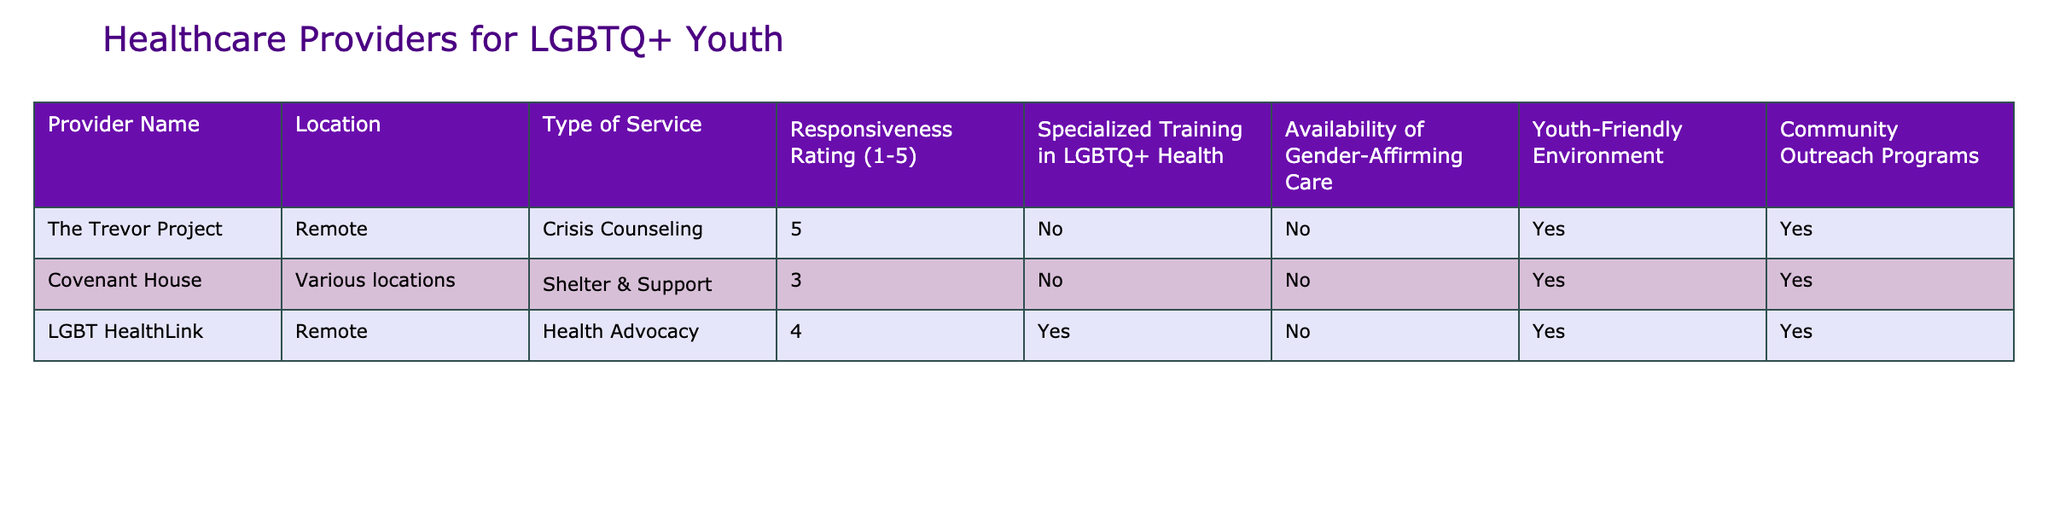What is the highest responsiveness rating among the providers? The table lists the responsiveness ratings for each provider. The ratings are 5 for The Trevor Project, 3 for Covenant House, and 4 for LGBT HealthLink. The highest rating is 5.
Answer: 5 Does any provider have specialized training in LGBTQ+ health? The table specifies whether each provider has specialized training in LGBTQ+ health. LGBT HealthLink is the only one that has this training, indicated by "Yes."
Answer: Yes Which provider has a youth-friendly environment and offers gender-affirming care? To find this, check both the "Youth-Friendly Environment" and "Availability of Gender-Affirming Care" columns. None of the providers has both; The Trevor Project and Covenant House have a youth-friendly environment but do not offer gender-affirming care.
Answer: None What is the average responsiveness rating of all providers? The responsiveness ratings are 5, 3, and 4. First, sum them: 5 + 3 + 4 = 12. Then, divide by the number of providers (3): 12 / 3 = 4. Therefore, the average is 4.
Answer: 4 How many providers have community outreach programs? Check the "Community Outreach Programs" column. The Trevor Project, Covenant House, and LGBT HealthLink all have "Yes" in this column, totaling three providers.
Answer: 3 Is there a provider that offers both youth-friendly environment and specialized training in LGBTQ+ health? Analyze the table to see which providers have "Yes" in both the "Youth-Friendly Environment" and "Specialized Training in LGBTQ+ Health" columns. Only LGBT HealthLink has specialized training but does not have a youth-friendly environment.
Answer: No What is the difference in responsiveness ratings between the highest and lowest rated providers? Identify the highest rating (5 from The Trevor Project) and the lowest rating (3 from Covenant House). The difference is 5 - 3 = 2.
Answer: 2 Which provider has the least availability for gender-affirming care? The "Availability of Gender-Affirming Care" column shows that The Trevor Project and Covenant House both have "No" while LGBT HealthLink has "No" as well. Therefore, they are tied in having the least availability as none offer it.
Answer: The Trevor Project and Covenant House 